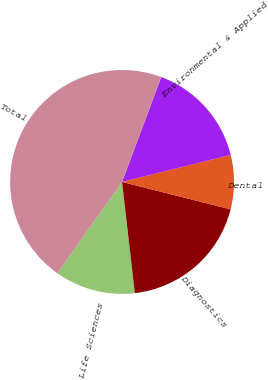<chart> <loc_0><loc_0><loc_500><loc_500><pie_chart><fcel>Life Sciences<fcel>Diagnostics<fcel>Dental<fcel>Environmental & Applied<fcel>Total<nl><fcel>11.63%<fcel>19.24%<fcel>7.82%<fcel>15.43%<fcel>45.88%<nl></chart> 